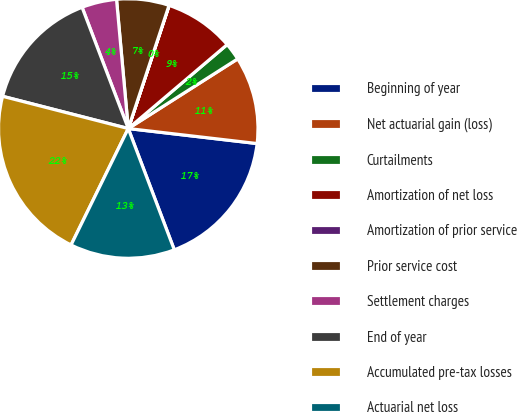Convert chart. <chart><loc_0><loc_0><loc_500><loc_500><pie_chart><fcel>Beginning of year<fcel>Net actuarial gain (loss)<fcel>Curtailments<fcel>Amortization of net loss<fcel>Amortization of prior service<fcel>Prior service cost<fcel>Settlement charges<fcel>End of year<fcel>Accumulated pre-tax losses<fcel>Actuarial net loss<nl><fcel>17.38%<fcel>10.87%<fcel>2.18%<fcel>8.7%<fcel>0.01%<fcel>6.53%<fcel>4.35%<fcel>15.21%<fcel>21.73%<fcel>13.04%<nl></chart> 